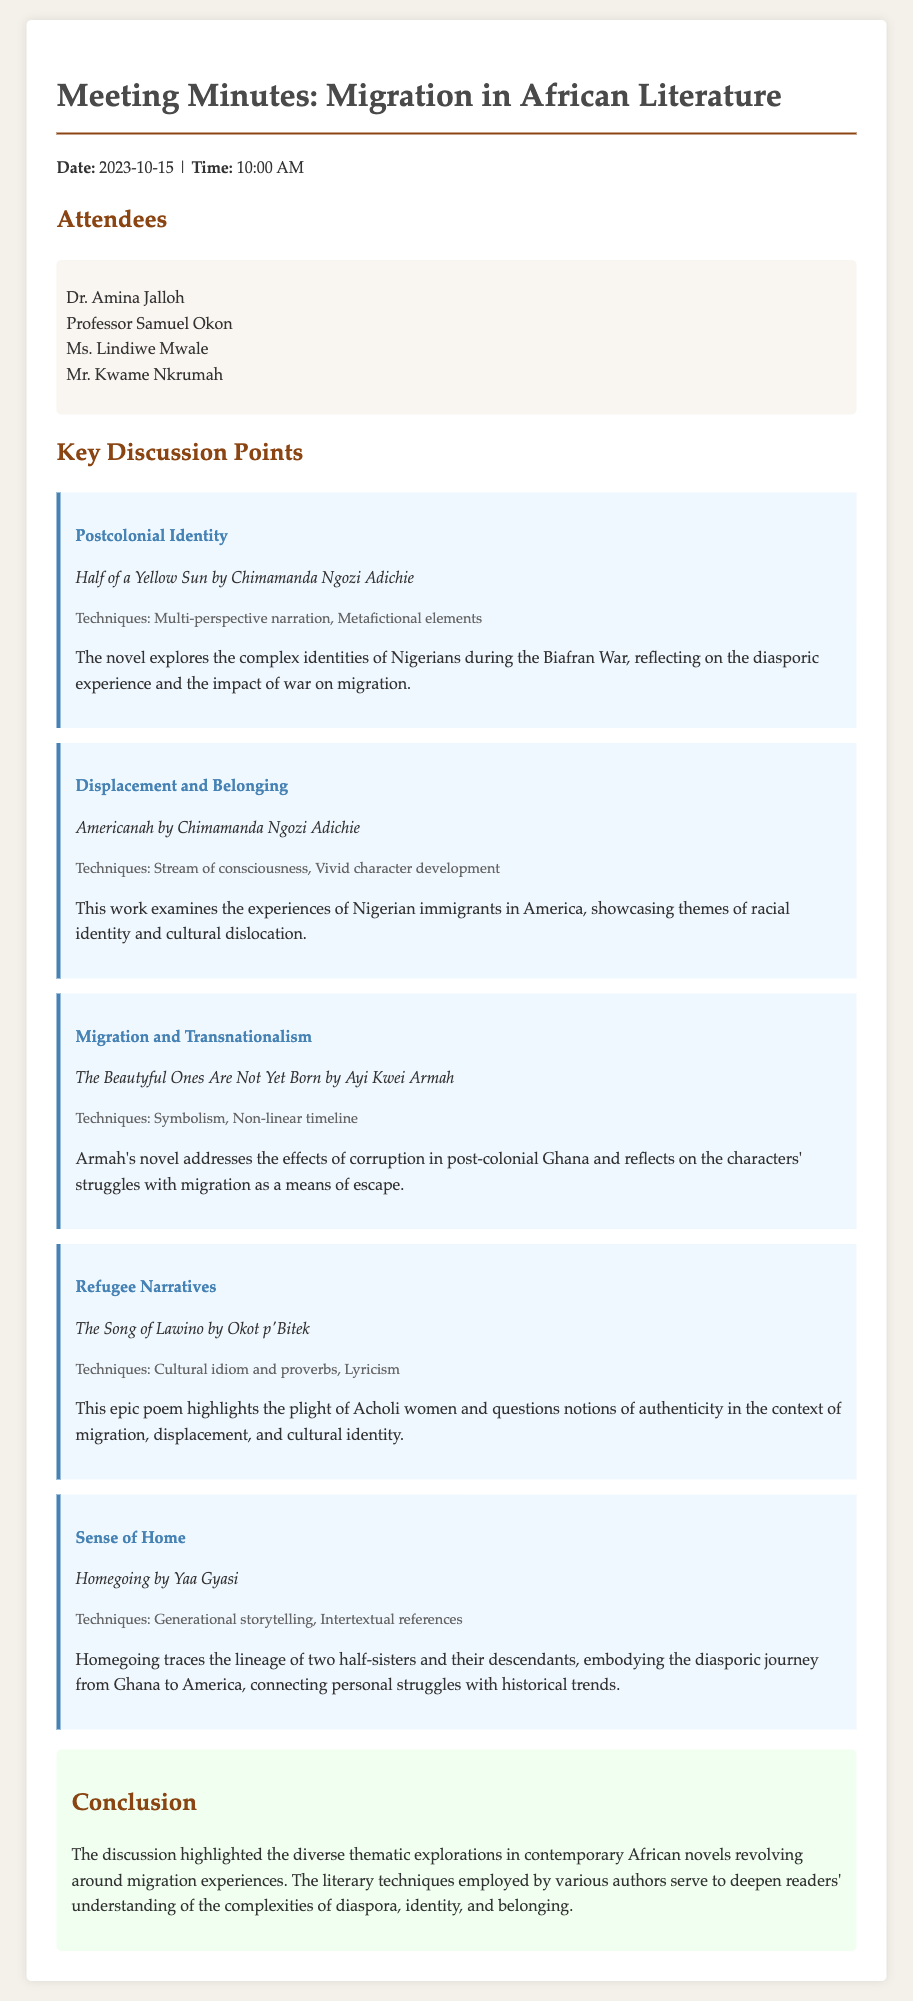What is the date of the meeting? The date of the meeting is provided in the document header.
Answer: 2023-10-15 Who is one of the attendees? The names of the attendees are listed in the attendees section of the document.
Answer: Dr. Amina Jalloh What novel is associated with the theme of "Displacement and Belonging"? The document lists themes along with the corresponding novels discussed during the meeting.
Answer: Americanah Which literary technique is used in "Homegoing"? The document mentions the literary techniques in each key point discussed.
Answer: Generational storytelling What theme is explored in "The Beautyful Ones Are Not Yet Born"? Each novel mentioned in the document is associated with a specific theme.
Answer: Migration and Transnationalism How many attendees were present at the meeting? The number of attendees can be counted from the list in the document.
Answer: 4 What is the conclusion of the meeting? The conclusion is summarized in its own section at the end of the document.
Answer: The discussion highlighted the diverse thematic explorations in contemporary African novels Which author wrote "The Song of Lawino"? The document attributes specific works to their authors in the key points.
Answer: Okot p'Bitek 